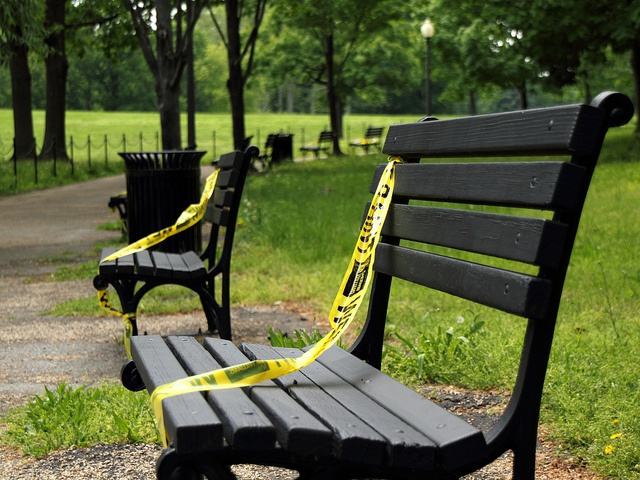Describe the objects in this image and their specific colors. I can see bench in black, darkgray, gray, and darkgreen tones, bench in black, gray, and darkgreen tones, bench in black, darkgreen, and gray tones, bench in black, darkgreen, gray, and olive tones, and bench in black, darkgreen, olive, and gray tones in this image. 